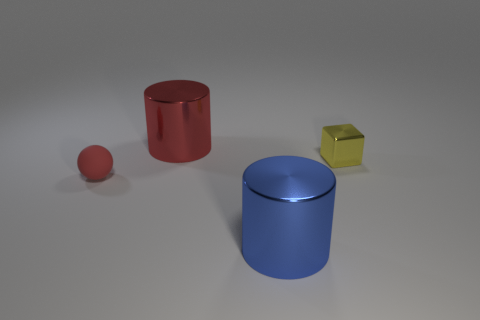Add 3 small spheres. How many objects exist? 7 Subtract all balls. How many objects are left? 3 Add 2 tiny red matte spheres. How many tiny red matte spheres are left? 3 Add 2 shiny blocks. How many shiny blocks exist? 3 Subtract 0 gray cubes. How many objects are left? 4 Subtract all tiny yellow cubes. Subtract all red things. How many objects are left? 1 